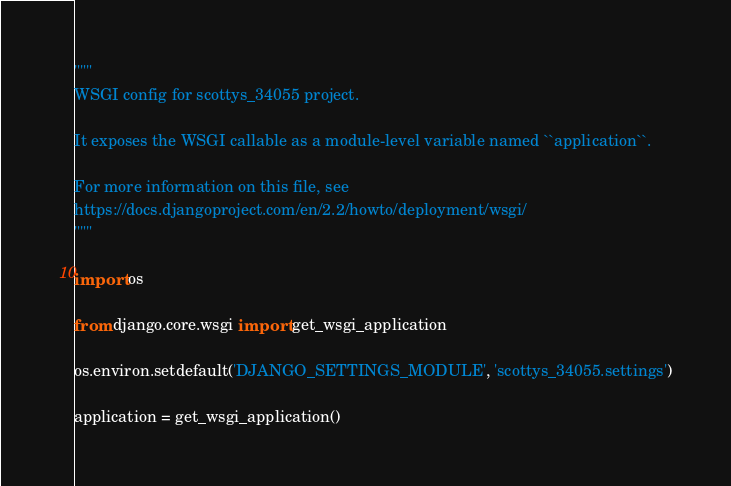Convert code to text. <code><loc_0><loc_0><loc_500><loc_500><_Python_>"""
WSGI config for scottys_34055 project.

It exposes the WSGI callable as a module-level variable named ``application``.

For more information on this file, see
https://docs.djangoproject.com/en/2.2/howto/deployment/wsgi/
"""

import os

from django.core.wsgi import get_wsgi_application

os.environ.setdefault('DJANGO_SETTINGS_MODULE', 'scottys_34055.settings')

application = get_wsgi_application()
</code> 